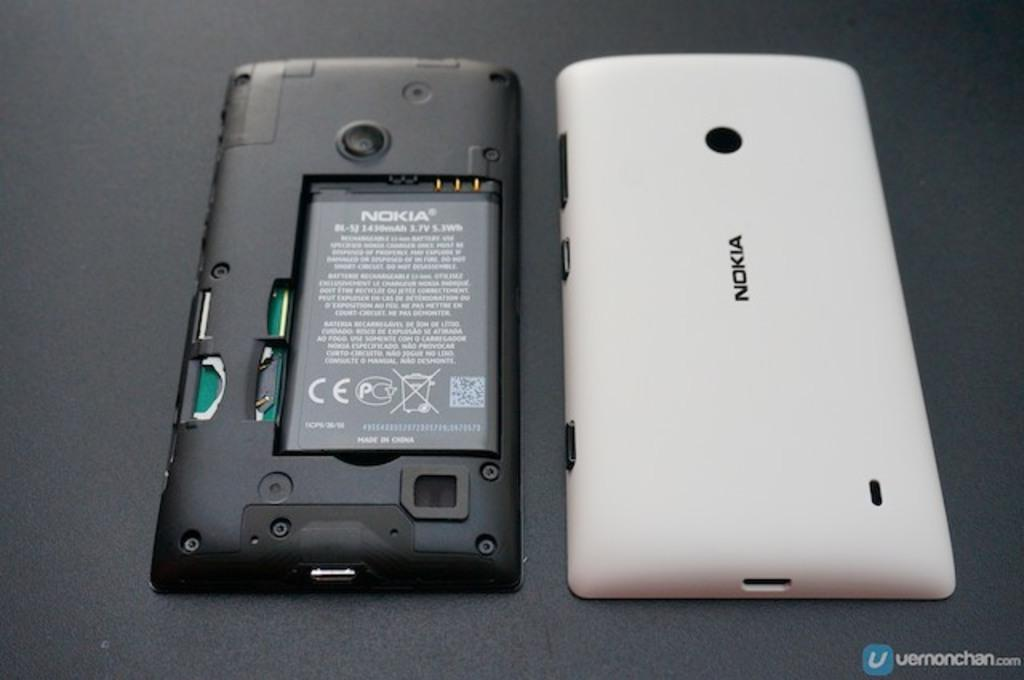<image>
Share a concise interpretation of the image provided. a white Nokia phone's back and exposed battery 